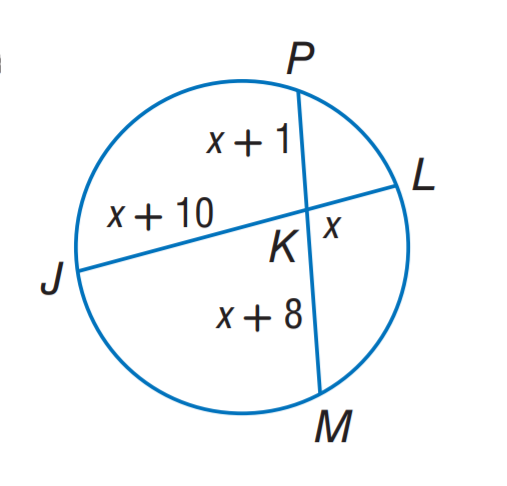Answer the mathemtical geometry problem and directly provide the correct option letter.
Question: Find x.
Choices: A: 7 B: 8 C: 9 D: 10 B 